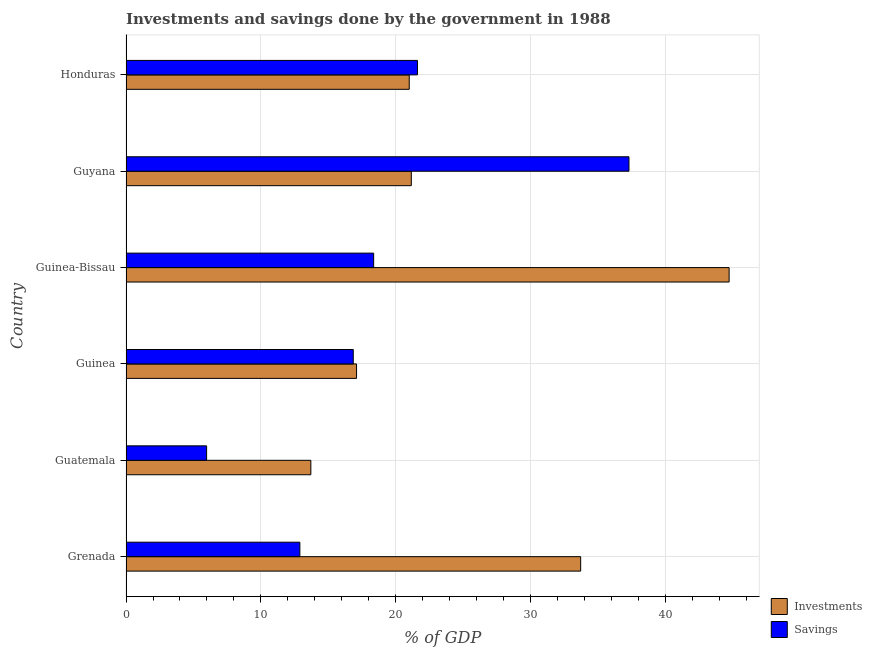How many different coloured bars are there?
Offer a very short reply. 2. Are the number of bars per tick equal to the number of legend labels?
Provide a succinct answer. Yes. Are the number of bars on each tick of the Y-axis equal?
Make the answer very short. Yes. How many bars are there on the 3rd tick from the bottom?
Your answer should be very brief. 2. What is the label of the 5th group of bars from the top?
Provide a succinct answer. Guatemala. In how many cases, is the number of bars for a given country not equal to the number of legend labels?
Your answer should be very brief. 0. What is the investments of government in Guinea?
Your answer should be compact. 17.09. Across all countries, what is the maximum investments of government?
Make the answer very short. 44.7. Across all countries, what is the minimum investments of government?
Your answer should be compact. 13.7. In which country was the investments of government maximum?
Provide a succinct answer. Guinea-Bissau. In which country was the savings of government minimum?
Your answer should be compact. Guatemala. What is the total investments of government in the graph?
Keep it short and to the point. 151.32. What is the difference between the investments of government in Grenada and that in Guinea?
Provide a succinct answer. 16.61. What is the difference between the savings of government in Grenada and the investments of government in Guinea?
Offer a very short reply. -4.2. What is the average investments of government per country?
Provide a short and direct response. 25.22. What is the difference between the savings of government and investments of government in Guinea-Bissau?
Your answer should be very brief. -26.35. In how many countries, is the savings of government greater than 40 %?
Provide a short and direct response. 0. What is the ratio of the investments of government in Guatemala to that in Guinea?
Your response must be concise. 0.8. Is the investments of government in Guatemala less than that in Guinea-Bissau?
Your answer should be compact. Yes. What is the difference between the highest and the second highest savings of government?
Your answer should be very brief. 15.68. What is the difference between the highest and the lowest savings of government?
Provide a succinct answer. 31.3. In how many countries, is the savings of government greater than the average savings of government taken over all countries?
Give a very brief answer. 2. What does the 2nd bar from the top in Guinea-Bissau represents?
Provide a short and direct response. Investments. What does the 1st bar from the bottom in Guatemala represents?
Provide a short and direct response. Investments. Are all the bars in the graph horizontal?
Make the answer very short. Yes. What is the difference between two consecutive major ticks on the X-axis?
Keep it short and to the point. 10. Does the graph contain any zero values?
Offer a very short reply. No. Does the graph contain grids?
Offer a very short reply. Yes. How many legend labels are there?
Your response must be concise. 2. How are the legend labels stacked?
Keep it short and to the point. Vertical. What is the title of the graph?
Offer a very short reply. Investments and savings done by the government in 1988. What is the label or title of the X-axis?
Provide a succinct answer. % of GDP. What is the % of GDP of Investments in Grenada?
Offer a very short reply. 33.7. What is the % of GDP of Savings in Grenada?
Provide a succinct answer. 12.89. What is the % of GDP in Investments in Guatemala?
Provide a short and direct response. 13.7. What is the % of GDP of Savings in Guatemala?
Keep it short and to the point. 5.97. What is the % of GDP of Investments in Guinea?
Offer a terse response. 17.09. What is the % of GDP of Savings in Guinea?
Offer a terse response. 16.84. What is the % of GDP in Investments in Guinea-Bissau?
Provide a short and direct response. 44.7. What is the % of GDP in Savings in Guinea-Bissau?
Make the answer very short. 18.35. What is the % of GDP in Investments in Guyana?
Provide a short and direct response. 21.15. What is the % of GDP in Savings in Guyana?
Your answer should be very brief. 37.28. What is the % of GDP of Investments in Honduras?
Your answer should be compact. 20.99. What is the % of GDP in Savings in Honduras?
Give a very brief answer. 21.6. Across all countries, what is the maximum % of GDP of Investments?
Provide a short and direct response. 44.7. Across all countries, what is the maximum % of GDP of Savings?
Provide a succinct answer. 37.28. Across all countries, what is the minimum % of GDP in Investments?
Provide a succinct answer. 13.7. Across all countries, what is the minimum % of GDP of Savings?
Offer a terse response. 5.97. What is the total % of GDP of Investments in the graph?
Offer a very short reply. 151.32. What is the total % of GDP in Savings in the graph?
Provide a short and direct response. 112.94. What is the difference between the % of GDP in Investments in Grenada and that in Guatemala?
Ensure brevity in your answer.  20. What is the difference between the % of GDP of Savings in Grenada and that in Guatemala?
Offer a very short reply. 6.91. What is the difference between the % of GDP in Investments in Grenada and that in Guinea?
Make the answer very short. 16.61. What is the difference between the % of GDP in Savings in Grenada and that in Guinea?
Provide a short and direct response. -3.96. What is the difference between the % of GDP of Investments in Grenada and that in Guinea-Bissau?
Your answer should be compact. -11. What is the difference between the % of GDP of Savings in Grenada and that in Guinea-Bissau?
Your answer should be very brief. -5.47. What is the difference between the % of GDP of Investments in Grenada and that in Guyana?
Offer a very short reply. 12.55. What is the difference between the % of GDP of Savings in Grenada and that in Guyana?
Your answer should be very brief. -24.39. What is the difference between the % of GDP in Investments in Grenada and that in Honduras?
Ensure brevity in your answer.  12.71. What is the difference between the % of GDP of Savings in Grenada and that in Honduras?
Your response must be concise. -8.72. What is the difference between the % of GDP in Investments in Guatemala and that in Guinea?
Provide a succinct answer. -3.39. What is the difference between the % of GDP of Savings in Guatemala and that in Guinea?
Your answer should be compact. -10.87. What is the difference between the % of GDP of Investments in Guatemala and that in Guinea-Bissau?
Provide a succinct answer. -31. What is the difference between the % of GDP of Savings in Guatemala and that in Guinea-Bissau?
Offer a very short reply. -12.38. What is the difference between the % of GDP of Investments in Guatemala and that in Guyana?
Your response must be concise. -7.45. What is the difference between the % of GDP in Savings in Guatemala and that in Guyana?
Offer a terse response. -31.3. What is the difference between the % of GDP of Investments in Guatemala and that in Honduras?
Make the answer very short. -7.29. What is the difference between the % of GDP of Savings in Guatemala and that in Honduras?
Your response must be concise. -15.63. What is the difference between the % of GDP of Investments in Guinea and that in Guinea-Bissau?
Provide a succinct answer. -27.61. What is the difference between the % of GDP in Savings in Guinea and that in Guinea-Bissau?
Make the answer very short. -1.51. What is the difference between the % of GDP of Investments in Guinea and that in Guyana?
Offer a very short reply. -4.06. What is the difference between the % of GDP of Savings in Guinea and that in Guyana?
Offer a terse response. -20.43. What is the difference between the % of GDP in Investments in Guinea and that in Honduras?
Your response must be concise. -3.9. What is the difference between the % of GDP of Savings in Guinea and that in Honduras?
Give a very brief answer. -4.76. What is the difference between the % of GDP in Investments in Guinea-Bissau and that in Guyana?
Offer a terse response. 23.56. What is the difference between the % of GDP of Savings in Guinea-Bissau and that in Guyana?
Offer a terse response. -18.92. What is the difference between the % of GDP in Investments in Guinea-Bissau and that in Honduras?
Give a very brief answer. 23.71. What is the difference between the % of GDP of Savings in Guinea-Bissau and that in Honduras?
Offer a terse response. -3.25. What is the difference between the % of GDP of Investments in Guyana and that in Honduras?
Provide a short and direct response. 0.15. What is the difference between the % of GDP in Savings in Guyana and that in Honduras?
Make the answer very short. 15.68. What is the difference between the % of GDP in Investments in Grenada and the % of GDP in Savings in Guatemala?
Your answer should be compact. 27.72. What is the difference between the % of GDP in Investments in Grenada and the % of GDP in Savings in Guinea?
Your answer should be compact. 16.85. What is the difference between the % of GDP of Investments in Grenada and the % of GDP of Savings in Guinea-Bissau?
Ensure brevity in your answer.  15.34. What is the difference between the % of GDP of Investments in Grenada and the % of GDP of Savings in Guyana?
Your answer should be very brief. -3.58. What is the difference between the % of GDP of Investments in Grenada and the % of GDP of Savings in Honduras?
Provide a short and direct response. 12.1. What is the difference between the % of GDP in Investments in Guatemala and the % of GDP in Savings in Guinea?
Provide a succinct answer. -3.14. What is the difference between the % of GDP of Investments in Guatemala and the % of GDP of Savings in Guinea-Bissau?
Your answer should be compact. -4.66. What is the difference between the % of GDP in Investments in Guatemala and the % of GDP in Savings in Guyana?
Give a very brief answer. -23.58. What is the difference between the % of GDP in Investments in Guatemala and the % of GDP in Savings in Honduras?
Ensure brevity in your answer.  -7.9. What is the difference between the % of GDP of Investments in Guinea and the % of GDP of Savings in Guinea-Bissau?
Provide a succinct answer. -1.27. What is the difference between the % of GDP of Investments in Guinea and the % of GDP of Savings in Guyana?
Give a very brief answer. -20.19. What is the difference between the % of GDP of Investments in Guinea and the % of GDP of Savings in Honduras?
Your answer should be compact. -4.51. What is the difference between the % of GDP of Investments in Guinea-Bissau and the % of GDP of Savings in Guyana?
Provide a succinct answer. 7.42. What is the difference between the % of GDP of Investments in Guinea-Bissau and the % of GDP of Savings in Honduras?
Offer a very short reply. 23.1. What is the difference between the % of GDP in Investments in Guyana and the % of GDP in Savings in Honduras?
Offer a terse response. -0.46. What is the average % of GDP of Investments per country?
Keep it short and to the point. 25.22. What is the average % of GDP of Savings per country?
Provide a short and direct response. 18.82. What is the difference between the % of GDP of Investments and % of GDP of Savings in Grenada?
Make the answer very short. 20.81. What is the difference between the % of GDP in Investments and % of GDP in Savings in Guatemala?
Your answer should be very brief. 7.73. What is the difference between the % of GDP of Investments and % of GDP of Savings in Guinea?
Your answer should be very brief. 0.24. What is the difference between the % of GDP in Investments and % of GDP in Savings in Guinea-Bissau?
Your response must be concise. 26.35. What is the difference between the % of GDP of Investments and % of GDP of Savings in Guyana?
Make the answer very short. -16.13. What is the difference between the % of GDP in Investments and % of GDP in Savings in Honduras?
Offer a very short reply. -0.61. What is the ratio of the % of GDP of Investments in Grenada to that in Guatemala?
Offer a very short reply. 2.46. What is the ratio of the % of GDP of Savings in Grenada to that in Guatemala?
Your answer should be compact. 2.16. What is the ratio of the % of GDP of Investments in Grenada to that in Guinea?
Provide a short and direct response. 1.97. What is the ratio of the % of GDP of Savings in Grenada to that in Guinea?
Ensure brevity in your answer.  0.77. What is the ratio of the % of GDP in Investments in Grenada to that in Guinea-Bissau?
Make the answer very short. 0.75. What is the ratio of the % of GDP in Savings in Grenada to that in Guinea-Bissau?
Your response must be concise. 0.7. What is the ratio of the % of GDP in Investments in Grenada to that in Guyana?
Give a very brief answer. 1.59. What is the ratio of the % of GDP in Savings in Grenada to that in Guyana?
Give a very brief answer. 0.35. What is the ratio of the % of GDP of Investments in Grenada to that in Honduras?
Give a very brief answer. 1.61. What is the ratio of the % of GDP in Savings in Grenada to that in Honduras?
Your answer should be very brief. 0.6. What is the ratio of the % of GDP of Investments in Guatemala to that in Guinea?
Keep it short and to the point. 0.8. What is the ratio of the % of GDP of Savings in Guatemala to that in Guinea?
Provide a short and direct response. 0.35. What is the ratio of the % of GDP of Investments in Guatemala to that in Guinea-Bissau?
Provide a short and direct response. 0.31. What is the ratio of the % of GDP of Savings in Guatemala to that in Guinea-Bissau?
Ensure brevity in your answer.  0.33. What is the ratio of the % of GDP in Investments in Guatemala to that in Guyana?
Your response must be concise. 0.65. What is the ratio of the % of GDP of Savings in Guatemala to that in Guyana?
Offer a very short reply. 0.16. What is the ratio of the % of GDP of Investments in Guatemala to that in Honduras?
Ensure brevity in your answer.  0.65. What is the ratio of the % of GDP of Savings in Guatemala to that in Honduras?
Ensure brevity in your answer.  0.28. What is the ratio of the % of GDP of Investments in Guinea to that in Guinea-Bissau?
Offer a very short reply. 0.38. What is the ratio of the % of GDP of Savings in Guinea to that in Guinea-Bissau?
Keep it short and to the point. 0.92. What is the ratio of the % of GDP in Investments in Guinea to that in Guyana?
Your answer should be compact. 0.81. What is the ratio of the % of GDP in Savings in Guinea to that in Guyana?
Offer a very short reply. 0.45. What is the ratio of the % of GDP in Investments in Guinea to that in Honduras?
Provide a succinct answer. 0.81. What is the ratio of the % of GDP of Savings in Guinea to that in Honduras?
Give a very brief answer. 0.78. What is the ratio of the % of GDP in Investments in Guinea-Bissau to that in Guyana?
Your answer should be very brief. 2.11. What is the ratio of the % of GDP in Savings in Guinea-Bissau to that in Guyana?
Give a very brief answer. 0.49. What is the ratio of the % of GDP in Investments in Guinea-Bissau to that in Honduras?
Your answer should be compact. 2.13. What is the ratio of the % of GDP of Savings in Guinea-Bissau to that in Honduras?
Provide a succinct answer. 0.85. What is the ratio of the % of GDP of Investments in Guyana to that in Honduras?
Provide a short and direct response. 1.01. What is the ratio of the % of GDP in Savings in Guyana to that in Honduras?
Offer a terse response. 1.73. What is the difference between the highest and the second highest % of GDP in Investments?
Ensure brevity in your answer.  11. What is the difference between the highest and the second highest % of GDP in Savings?
Your response must be concise. 15.68. What is the difference between the highest and the lowest % of GDP of Investments?
Ensure brevity in your answer.  31. What is the difference between the highest and the lowest % of GDP of Savings?
Your answer should be very brief. 31.3. 